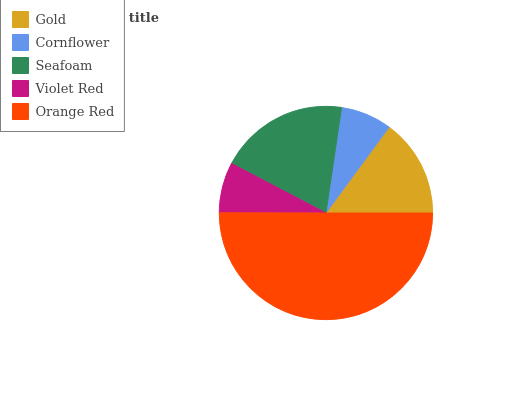Is Violet Red the minimum?
Answer yes or no. Yes. Is Orange Red the maximum?
Answer yes or no. Yes. Is Cornflower the minimum?
Answer yes or no. No. Is Cornflower the maximum?
Answer yes or no. No. Is Gold greater than Cornflower?
Answer yes or no. Yes. Is Cornflower less than Gold?
Answer yes or no. Yes. Is Cornflower greater than Gold?
Answer yes or no. No. Is Gold less than Cornflower?
Answer yes or no. No. Is Gold the high median?
Answer yes or no. Yes. Is Gold the low median?
Answer yes or no. Yes. Is Seafoam the high median?
Answer yes or no. No. Is Cornflower the low median?
Answer yes or no. No. 